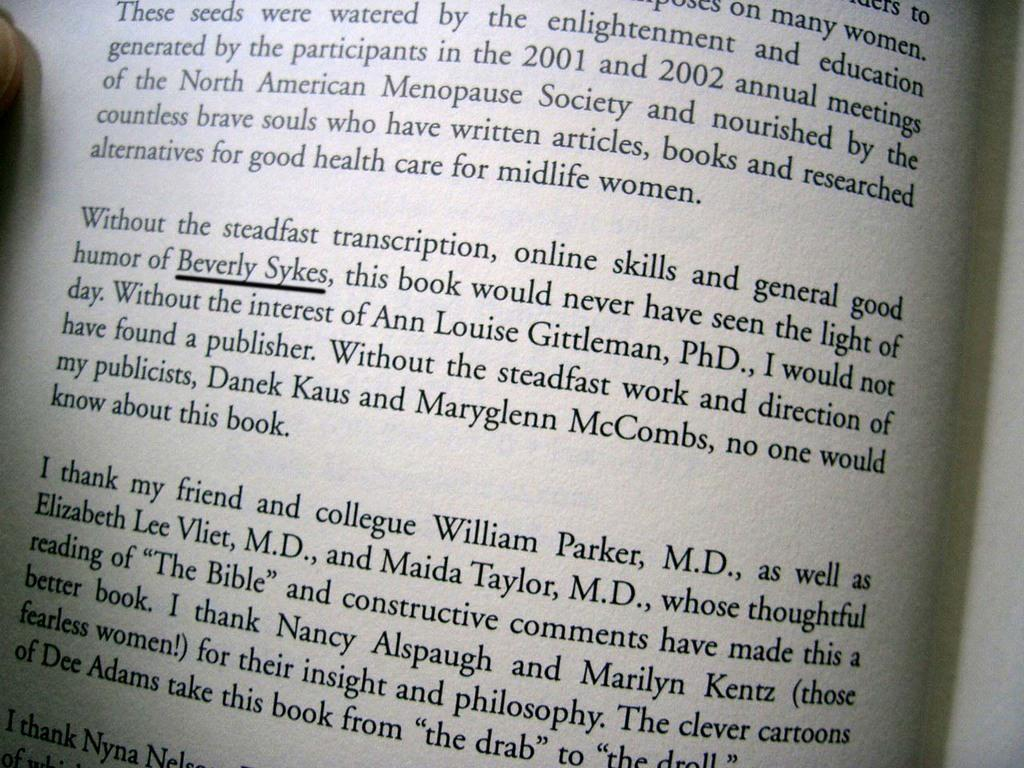<image>
Write a terse but informative summary of the picture. Open book on a page with the name Beverly Sykes underlined. 